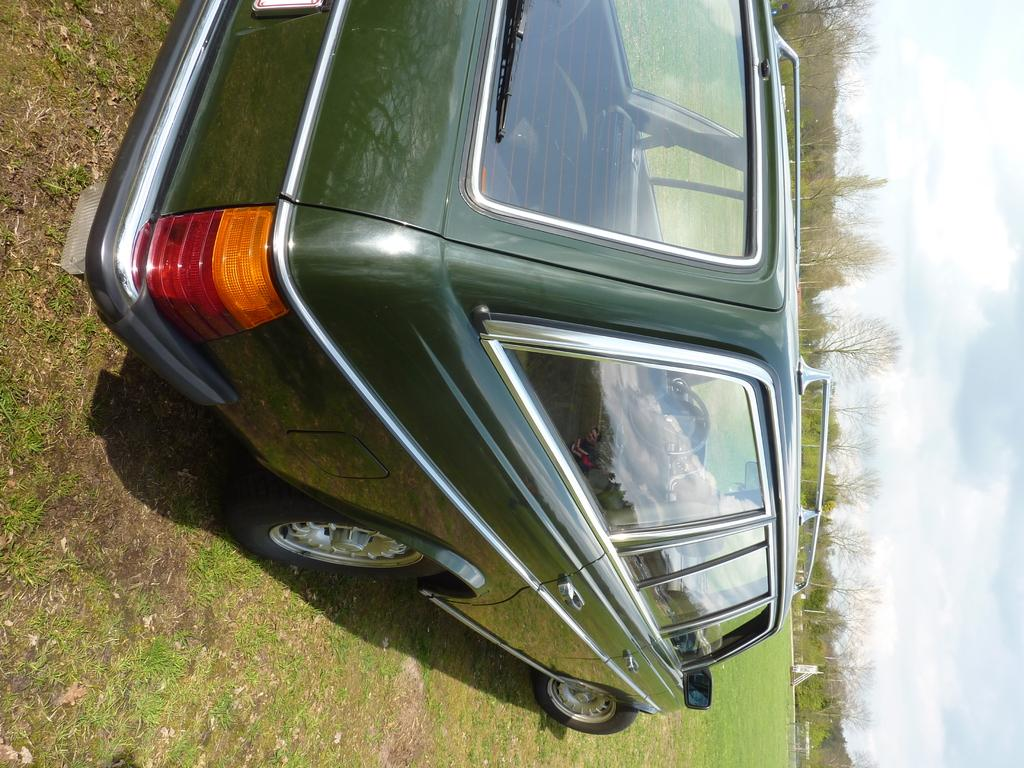What is the main subject of the image? There is a vehicle in the image. What type of natural environment is visible in the image? There are trees and grass on the ground in the image. What is visible in the sky in the image? The sky is visible in the image, and clouds are present. What type of silver mine can be seen in the image? There is no mine, silver or otherwise, present in the image. The image features a vehicle, trees, grass, and a sky with clouds. 